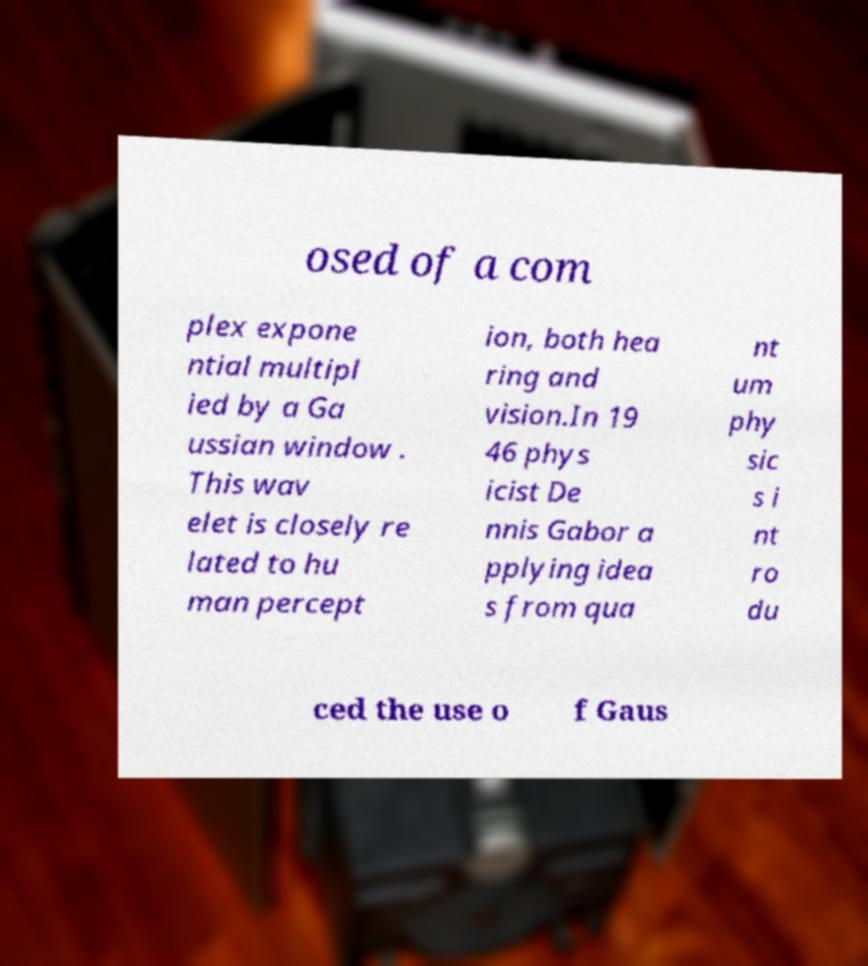I need the written content from this picture converted into text. Can you do that? osed of a com plex expone ntial multipl ied by a Ga ussian window . This wav elet is closely re lated to hu man percept ion, both hea ring and vision.In 19 46 phys icist De nnis Gabor a pplying idea s from qua nt um phy sic s i nt ro du ced the use o f Gaus 